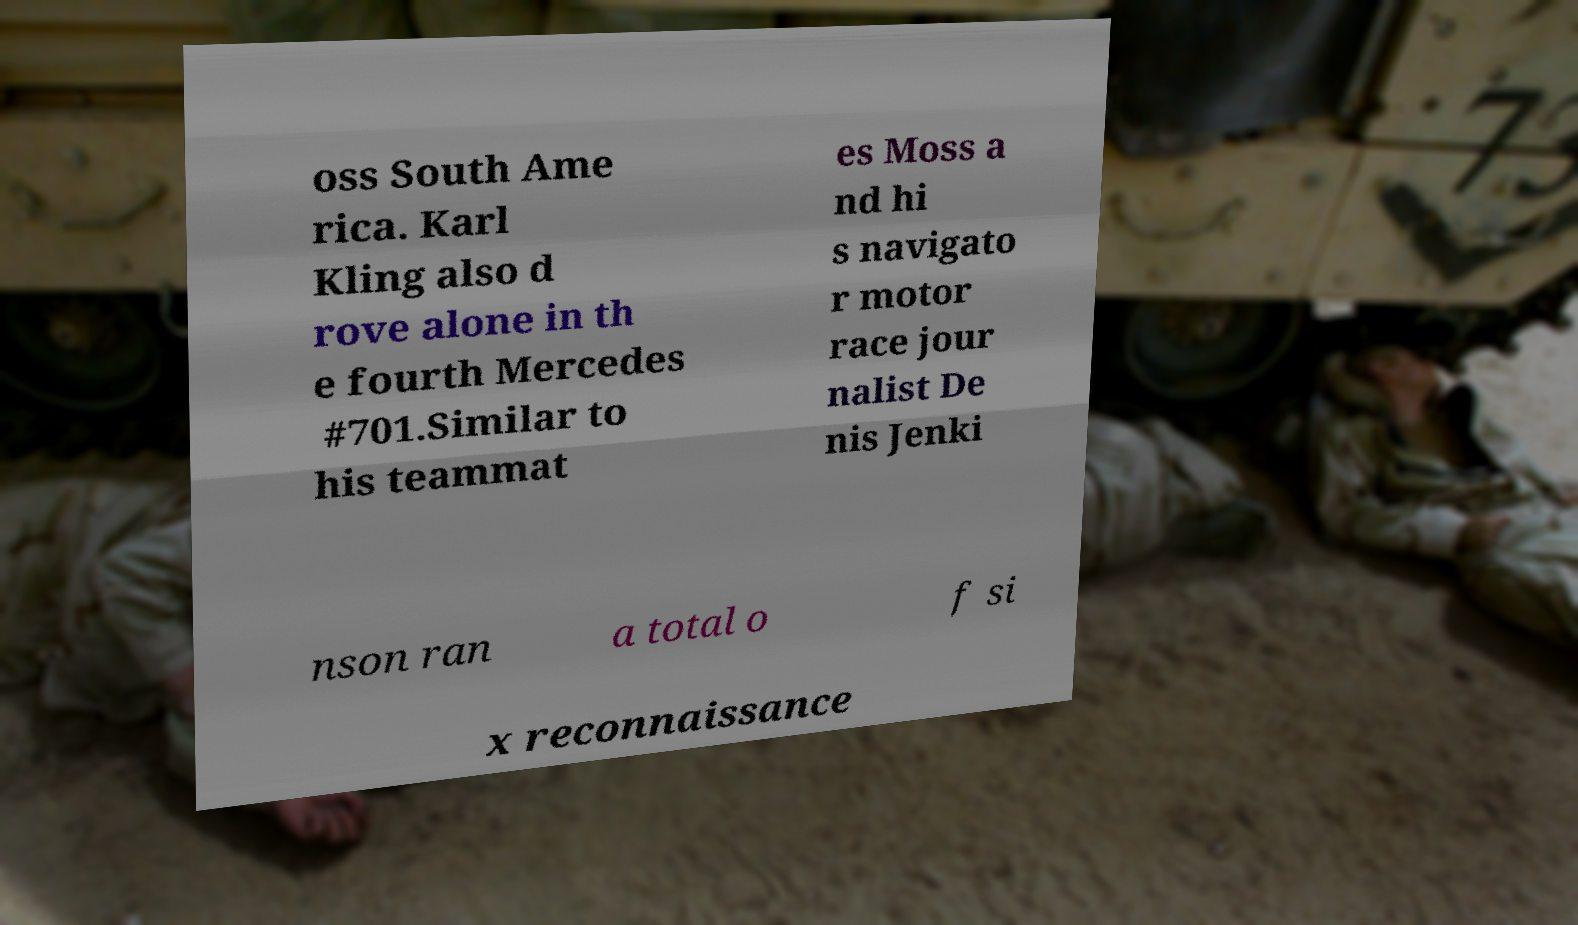For documentation purposes, I need the text within this image transcribed. Could you provide that? oss South Ame rica. Karl Kling also d rove alone in th e fourth Mercedes #701.Similar to his teammat es Moss a nd hi s navigato r motor race jour nalist De nis Jenki nson ran a total o f si x reconnaissance 